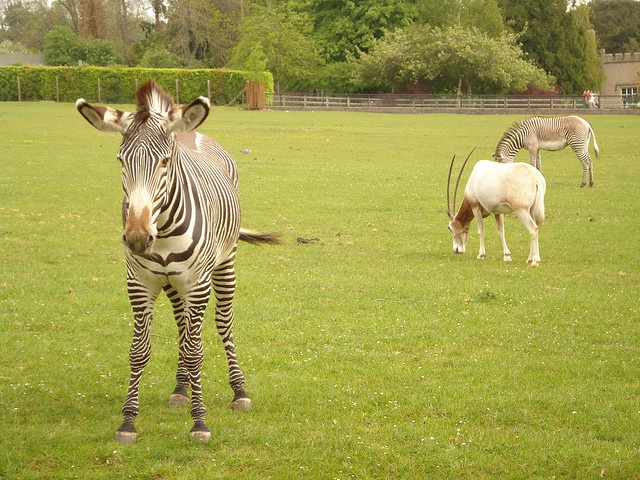Describe the objects in this image and their specific colors. I can see zebra in beige, tan, and olive tones, zebra in beige and tan tones, people in beige, white, and tan tones, and people in beige, gray, brown, salmon, and maroon tones in this image. 